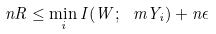<formula> <loc_0><loc_0><loc_500><loc_500>n R \leq \min _ { i } I ( W ; \ m { Y } _ { i } ) + n \epsilon</formula> 